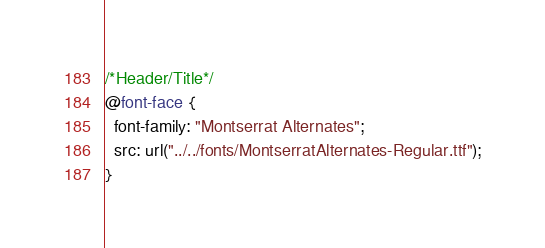<code> <loc_0><loc_0><loc_500><loc_500><_CSS_>/*Header/Title*/
@font-face {
  font-family: "Montserrat Alternates";
  src: url("../../fonts/MontserratAlternates-Regular.ttf");
}
</code> 